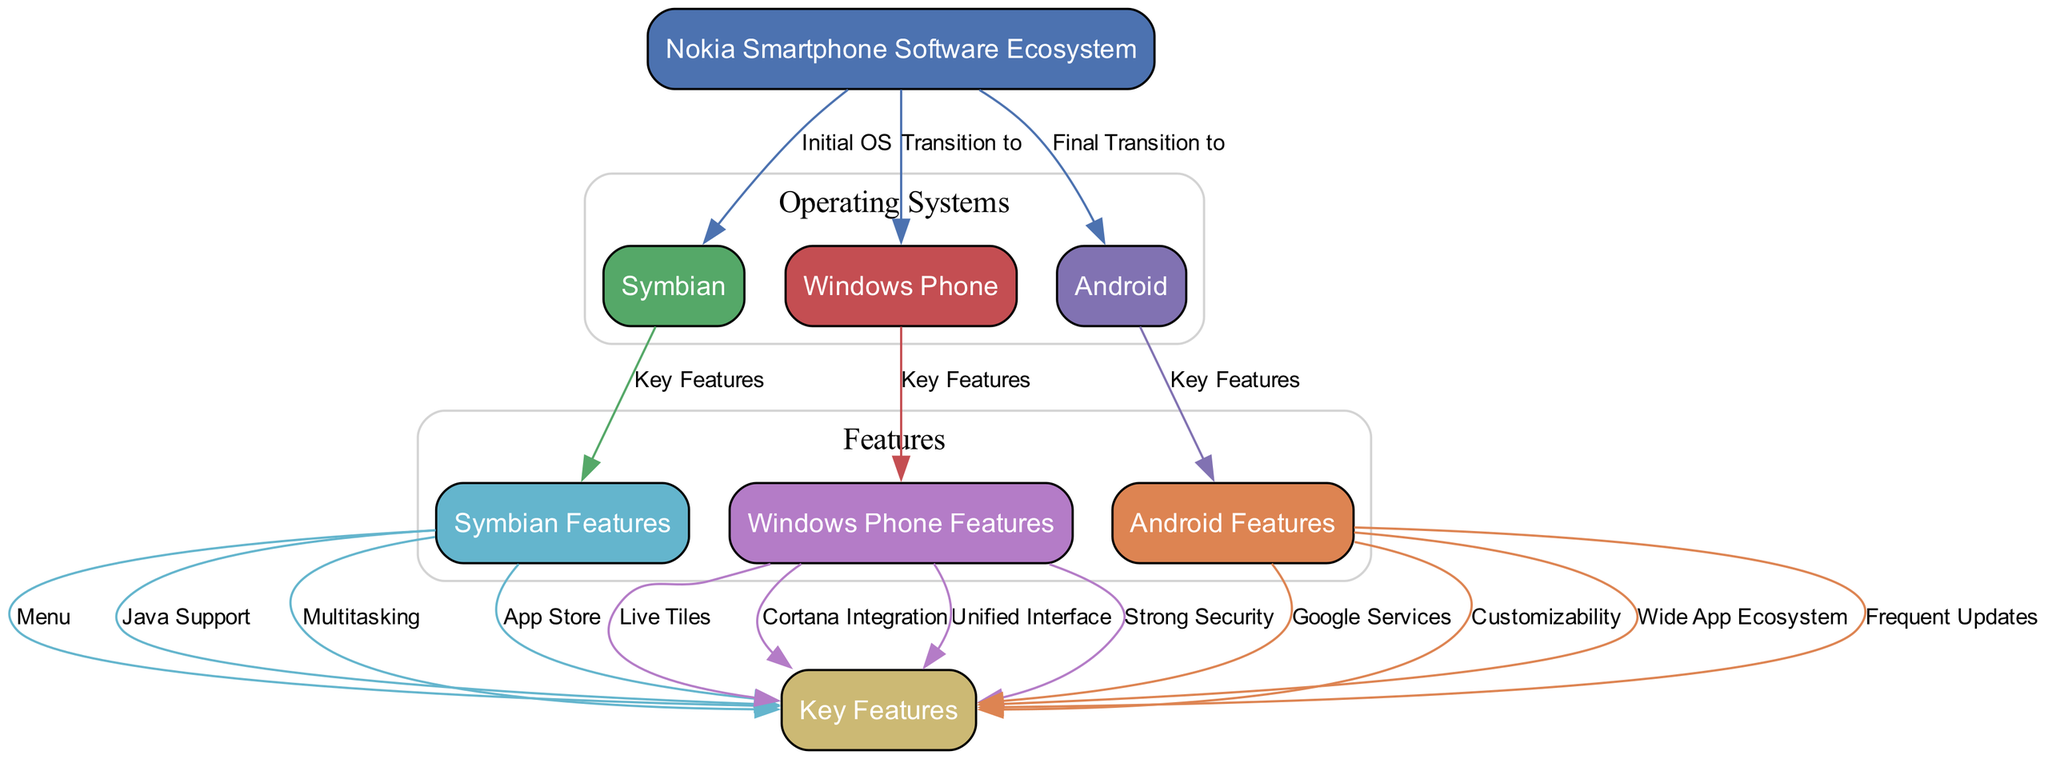What is the initial operating system shown in the diagram? The diagram indicates that the first operating system is Symbian, which is the node directly connected to the main node labeled "Nokia Smartphone Software Ecosystem" with the edge labeled "Initial OS."
Answer: Symbian How many operating systems are depicted in the diagram? The diagram includes three operating systems: Symbian, Windows Phone, and Android. This can be confirmed by counting the nodes that represent operating systems directly connected to the main node.
Answer: Three What kind of relationship is indicated between Nokia and Windows Phone? The diagram shows a directed edge labeled "Transition to" that connects the main node representing "Nokia Smartphone Software Ecosystem" to the node labeled "Windows Phone," indicating a transition.
Answer: Transition to List a key feature of the Symbian operating system. The diagram lists several key features of Symbian under the node labeled "Symbian Features," including "Menu," "Java Support," "Multitasking," and "App Store." Any one of these could serve as an answer.
Answer: Menu Which operating system features live tiles? The diagram presents a direct edge from the "Windows Phone Features" node to the "Key Features" node, with the specific feature "Live Tiles" mentioned. This indicates that live tiles are characteristic of Windows Phone.
Answer: Windows Phone What is the last transition in the Nokia software ecosystem? According to the diagram, the last transition indicated is "Final Transition to" which connects the main node to the Android node, suggesting that Android was the final operating system adopted.
Answer: Android Identify a key feature of the Android operating system. The Android node is connected to "Key Features" and lists several features including "Google Services," "Customizability," "Wide App Ecosystem," and "Frequent Updates." Any of these features can be identified as a key feature.
Answer: Google Services How many key features does Windows Phone have? The Windows Phone node connects to the "Key Features" node with edges for "Live Tiles," "Cortana Integration," "Unified Interface," and "Strong Security." This indicates a total of four key features listed for Windows Phone.
Answer: Four What color represents Symbian in the diagram? The color scheme shows that the node representing Symbian is colored with a specific shade, which is denoted by the hexadecimal code #55A868 in the diagram representation.
Answer: Green 